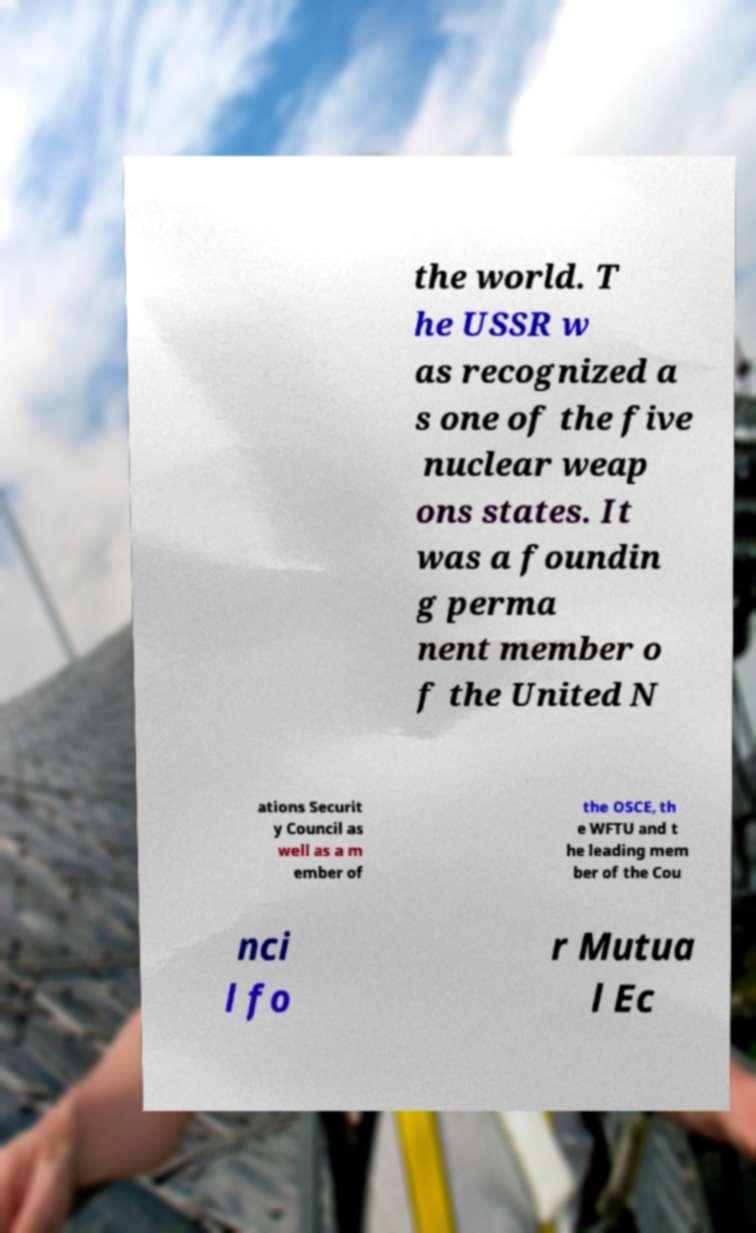Could you assist in decoding the text presented in this image and type it out clearly? the world. T he USSR w as recognized a s one of the five nuclear weap ons states. It was a foundin g perma nent member o f the United N ations Securit y Council as well as a m ember of the OSCE, th e WFTU and t he leading mem ber of the Cou nci l fo r Mutua l Ec 